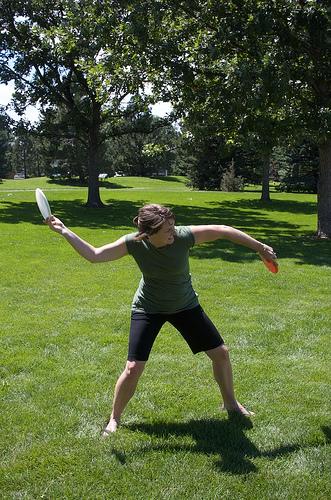What is the woman doing?
Give a very brief answer. Throwing frisbee. What color are her shorts?
Write a very short answer. Black. What kind of shoes is the woman wearing?
Be succinct. Flip flops. 